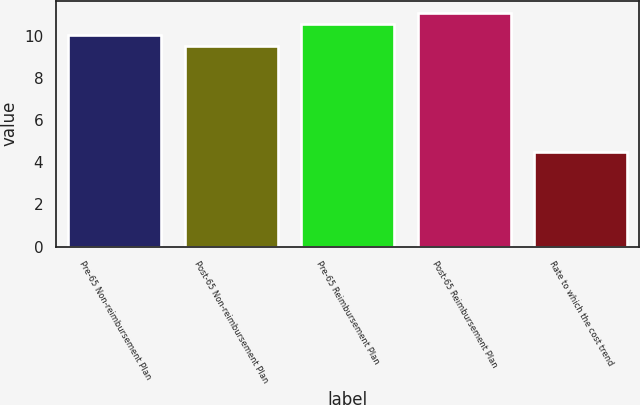<chart> <loc_0><loc_0><loc_500><loc_500><bar_chart><fcel>Pre-65 Non-reimbursement Plan<fcel>Post-65 Non-reimbursement Plan<fcel>Pre-65 Reimbursement Plan<fcel>Post-65 Reimbursement Plan<fcel>Rate to which the cost trend<nl><fcel>10.03<fcel>9.5<fcel>10.56<fcel>11.09<fcel>4.5<nl></chart> 